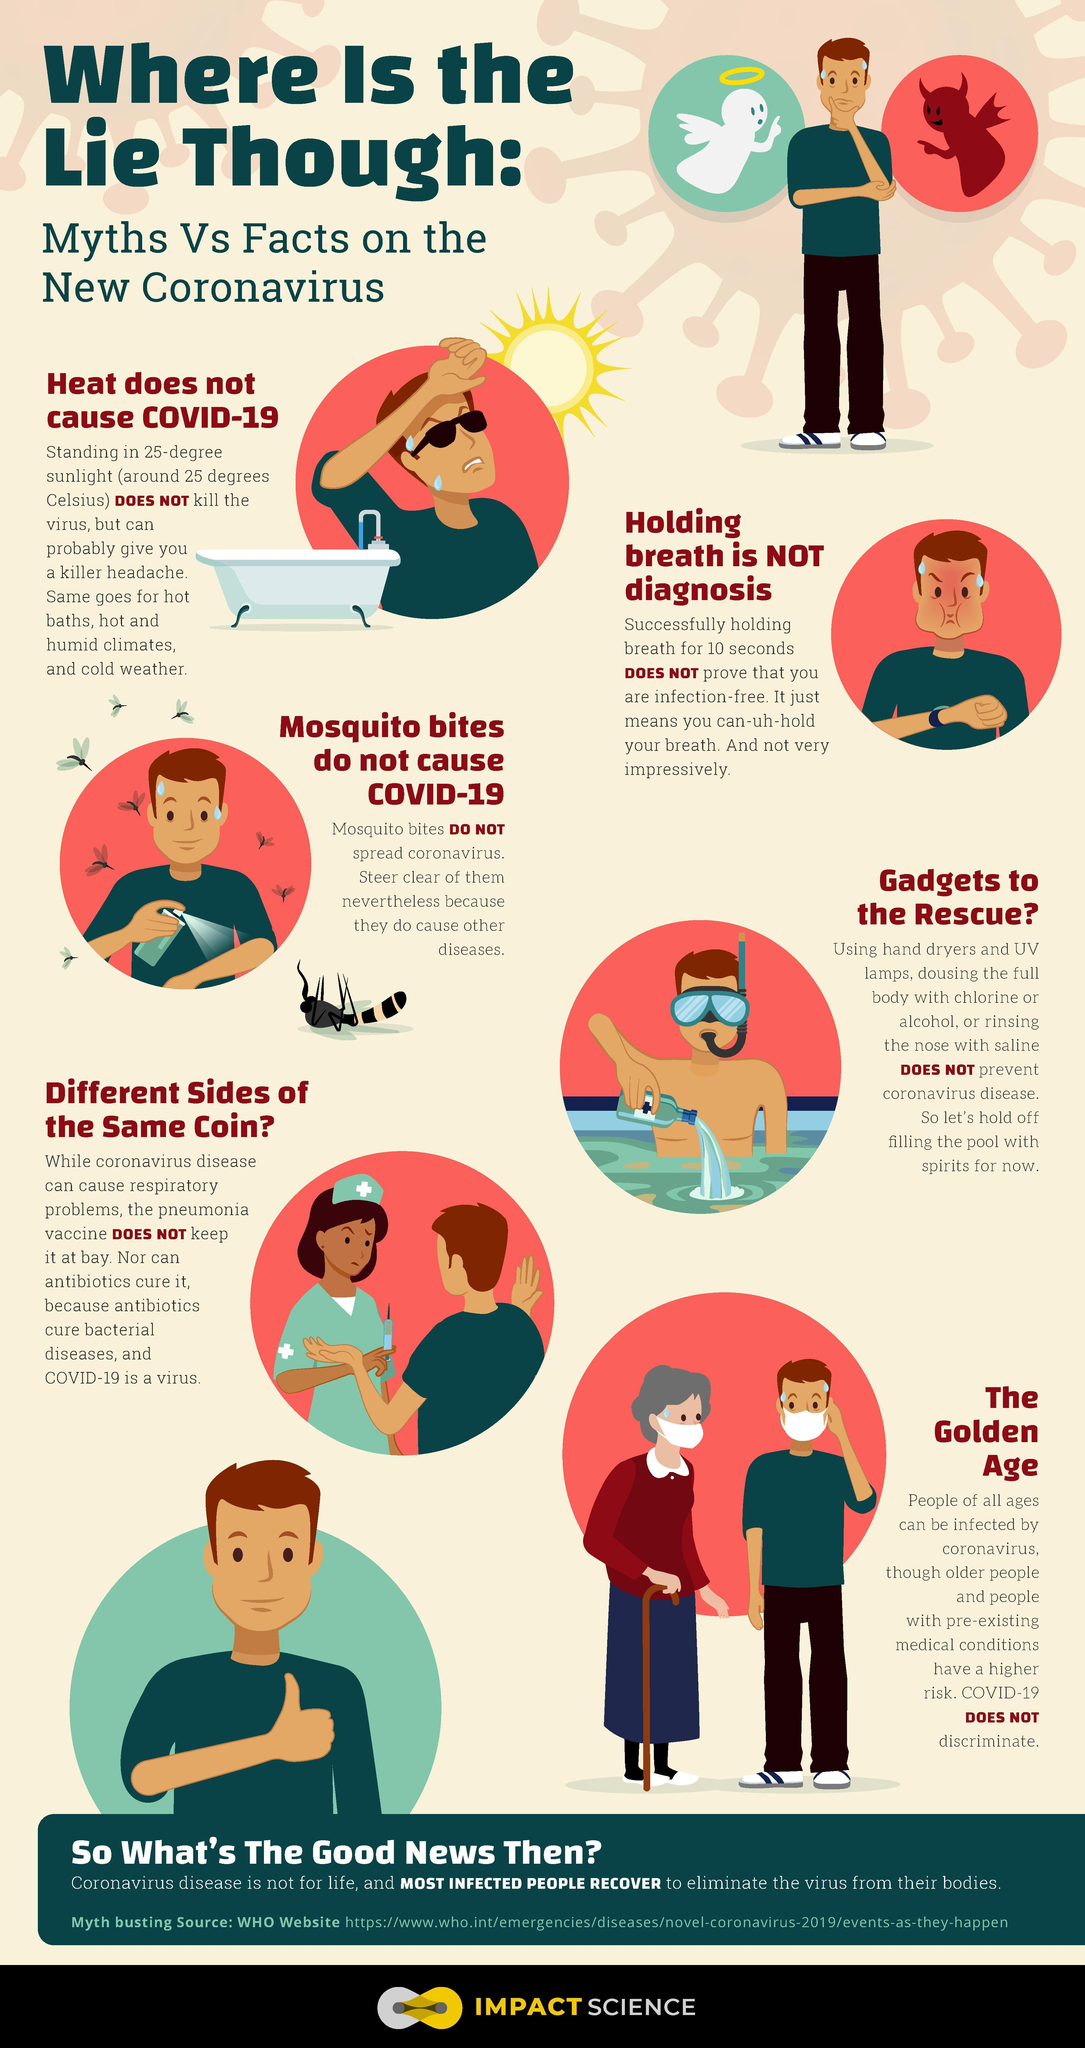How many people are with a mask in this infographic?
Answer the question with a short phrase. 2 Which medicines can heal bacterial diseases? Antibiotics 